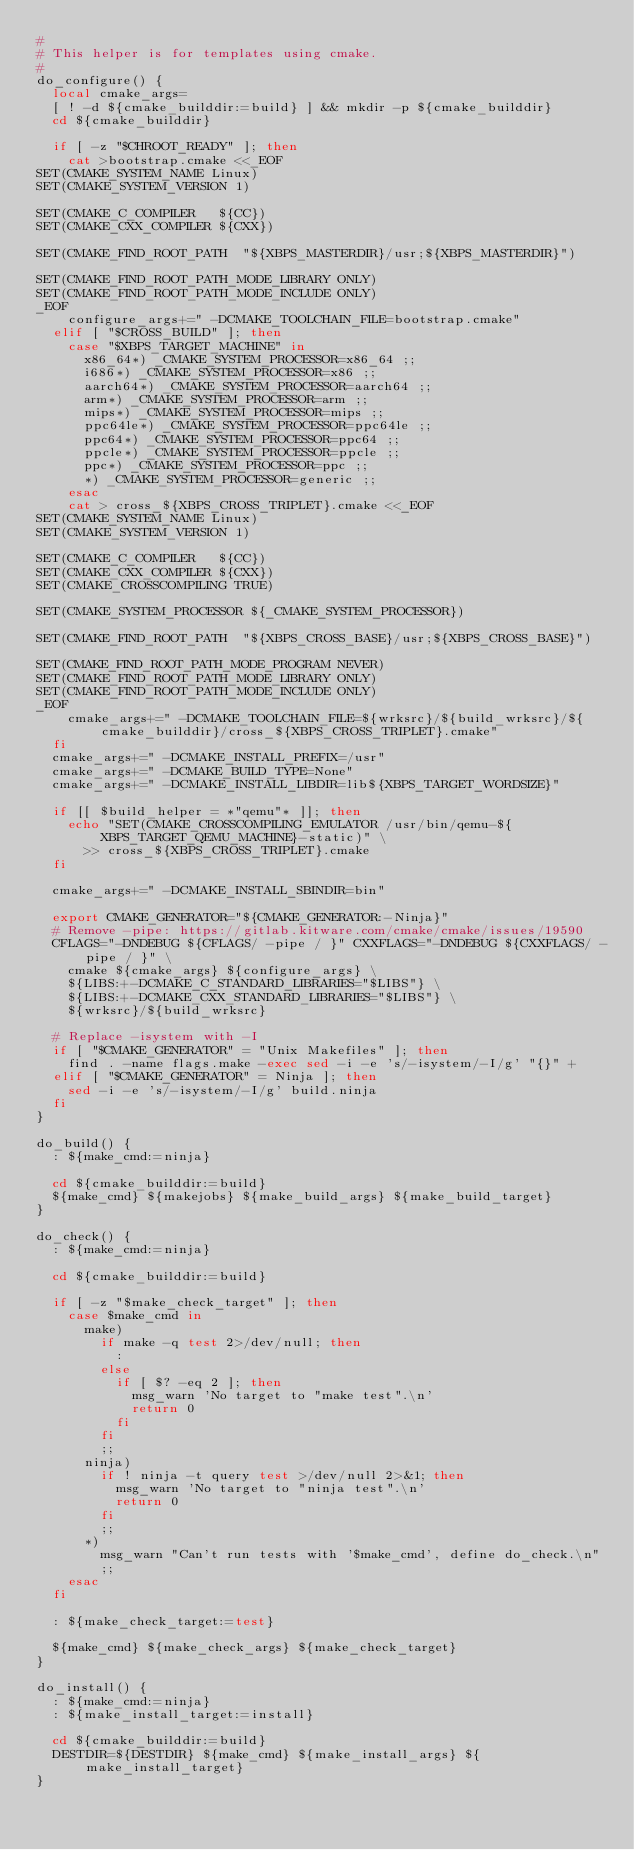Convert code to text. <code><loc_0><loc_0><loc_500><loc_500><_Bash_>#
# This helper is for templates using cmake.
#
do_configure() {
	local cmake_args=
	[ ! -d ${cmake_builddir:=build} ] && mkdir -p ${cmake_builddir}
	cd ${cmake_builddir}

	if [ -z "$CHROOT_READY" ]; then
		cat >bootstrap.cmake <<_EOF
SET(CMAKE_SYSTEM_NAME Linux)
SET(CMAKE_SYSTEM_VERSION 1)

SET(CMAKE_C_COMPILER   ${CC})
SET(CMAKE_CXX_COMPILER ${CXX})

SET(CMAKE_FIND_ROOT_PATH  "${XBPS_MASTERDIR}/usr;${XBPS_MASTERDIR}")

SET(CMAKE_FIND_ROOT_PATH_MODE_LIBRARY ONLY)
SET(CMAKE_FIND_ROOT_PATH_MODE_INCLUDE ONLY)
_EOF
		configure_args+=" -DCMAKE_TOOLCHAIN_FILE=bootstrap.cmake"
	elif [ "$CROSS_BUILD" ]; then
		case "$XBPS_TARGET_MACHINE" in
			x86_64*) _CMAKE_SYSTEM_PROCESSOR=x86_64 ;;
			i686*) _CMAKE_SYSTEM_PROCESSOR=x86 ;;
			aarch64*) _CMAKE_SYSTEM_PROCESSOR=aarch64 ;;
			arm*) _CMAKE_SYSTEM_PROCESSOR=arm ;;
			mips*) _CMAKE_SYSTEM_PROCESSOR=mips ;;
			ppc64le*) _CMAKE_SYSTEM_PROCESSOR=ppc64le ;;
			ppc64*) _CMAKE_SYSTEM_PROCESSOR=ppc64 ;;
			ppcle*) _CMAKE_SYSTEM_PROCESSOR=ppcle ;;
			ppc*) _CMAKE_SYSTEM_PROCESSOR=ppc ;;
			*) _CMAKE_SYSTEM_PROCESSOR=generic ;;
		esac
		cat > cross_${XBPS_CROSS_TRIPLET}.cmake <<_EOF
SET(CMAKE_SYSTEM_NAME Linux)
SET(CMAKE_SYSTEM_VERSION 1)

SET(CMAKE_C_COMPILER   ${CC})
SET(CMAKE_CXX_COMPILER ${CXX})
SET(CMAKE_CROSSCOMPILING TRUE)

SET(CMAKE_SYSTEM_PROCESSOR ${_CMAKE_SYSTEM_PROCESSOR})

SET(CMAKE_FIND_ROOT_PATH  "${XBPS_CROSS_BASE}/usr;${XBPS_CROSS_BASE}")

SET(CMAKE_FIND_ROOT_PATH_MODE_PROGRAM NEVER)
SET(CMAKE_FIND_ROOT_PATH_MODE_LIBRARY ONLY)
SET(CMAKE_FIND_ROOT_PATH_MODE_INCLUDE ONLY)
_EOF
		cmake_args+=" -DCMAKE_TOOLCHAIN_FILE=${wrksrc}/${build_wrksrc}/${cmake_builddir}/cross_${XBPS_CROSS_TRIPLET}.cmake"
	fi
	cmake_args+=" -DCMAKE_INSTALL_PREFIX=/usr"
	cmake_args+=" -DCMAKE_BUILD_TYPE=None"
	cmake_args+=" -DCMAKE_INSTALL_LIBDIR=lib${XBPS_TARGET_WORDSIZE}"

	if [[ $build_helper = *"qemu"* ]]; then
		echo "SET(CMAKE_CROSSCOMPILING_EMULATOR /usr/bin/qemu-${XBPS_TARGET_QEMU_MACHINE}-static)" \
			>> cross_${XBPS_CROSS_TRIPLET}.cmake
	fi

	cmake_args+=" -DCMAKE_INSTALL_SBINDIR=bin"

	export CMAKE_GENERATOR="${CMAKE_GENERATOR:-Ninja}"
	# Remove -pipe: https://gitlab.kitware.com/cmake/cmake/issues/19590
	CFLAGS="-DNDEBUG ${CFLAGS/ -pipe / }" CXXFLAGS="-DNDEBUG ${CXXFLAGS/ -pipe / }" \
		cmake ${cmake_args} ${configure_args} \
		${LIBS:+-DCMAKE_C_STANDARD_LIBRARIES="$LIBS"} \
		${LIBS:+-DCMAKE_CXX_STANDARD_LIBRARIES="$LIBS"} \
		${wrksrc}/${build_wrksrc}

	# Replace -isystem with -I
	if [ "$CMAKE_GENERATOR" = "Unix Makefiles" ]; then
		find . -name flags.make -exec sed -i -e 's/-isystem/-I/g' "{}" +
	elif [ "$CMAKE_GENERATOR" = Ninja ]; then
		sed -i -e 's/-isystem/-I/g' build.ninja
	fi
}

do_build() {
	: ${make_cmd:=ninja}

	cd ${cmake_builddir:=build}
	${make_cmd} ${makejobs} ${make_build_args} ${make_build_target}
}

do_check() {
	: ${make_cmd:=ninja}

	cd ${cmake_builddir:=build}

	if [ -z "$make_check_target" ]; then
		case $make_cmd in
			make)
				if make -q test 2>/dev/null; then
					:
				else
					if [ $? -eq 2 ]; then
						msg_warn 'No target to "make test".\n'
						return 0
					fi
				fi
				;;
			ninja)
				if ! ninja -t query test >/dev/null 2>&1; then
					msg_warn 'No target to "ninja test".\n'
					return 0
				fi
				;;
			*)
				msg_warn "Can't run tests with '$make_cmd', define do_check.\n"
				;;
		esac
	fi

	: ${make_check_target:=test}

	${make_cmd} ${make_check_args} ${make_check_target}
}

do_install() {
	: ${make_cmd:=ninja}
	: ${make_install_target:=install}

	cd ${cmake_builddir:=build}
	DESTDIR=${DESTDIR} ${make_cmd} ${make_install_args} ${make_install_target}
}
</code> 